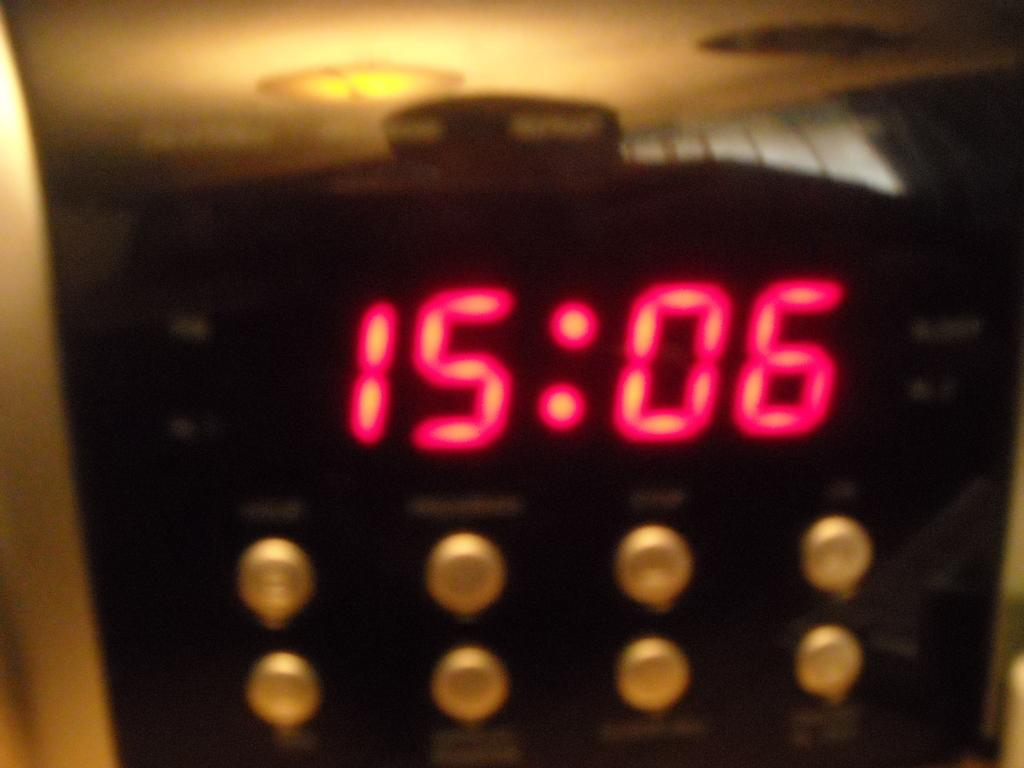<image>
Render a clear and concise summary of the photo. An electronic clock with buttons that has the time of 15:06 on the screen. 